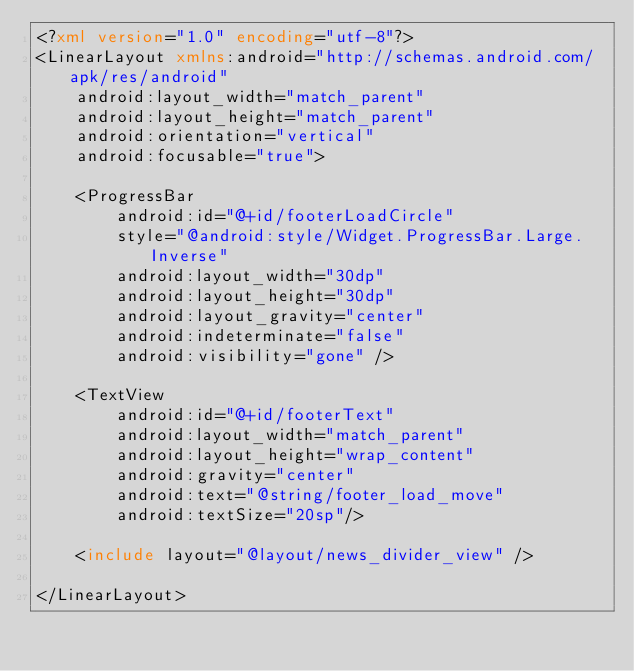<code> <loc_0><loc_0><loc_500><loc_500><_XML_><?xml version="1.0" encoding="utf-8"?>
<LinearLayout xmlns:android="http://schemas.android.com/apk/res/android"
    android:layout_width="match_parent"
    android:layout_height="match_parent"
    android:orientation="vertical"
    android:focusable="true">

    <ProgressBar
        android:id="@+id/footerLoadCircle"
        style="@android:style/Widget.ProgressBar.Large.Inverse"
        android:layout_width="30dp"
        android:layout_height="30dp"
        android:layout_gravity="center"
        android:indeterminate="false"
        android:visibility="gone" />

    <TextView
        android:id="@+id/footerText"
        android:layout_width="match_parent"
        android:layout_height="wrap_content"
        android:gravity="center"
        android:text="@string/footer_load_move"
        android:textSize="20sp"/>

    <include layout="@layout/news_divider_view" />

</LinearLayout></code> 